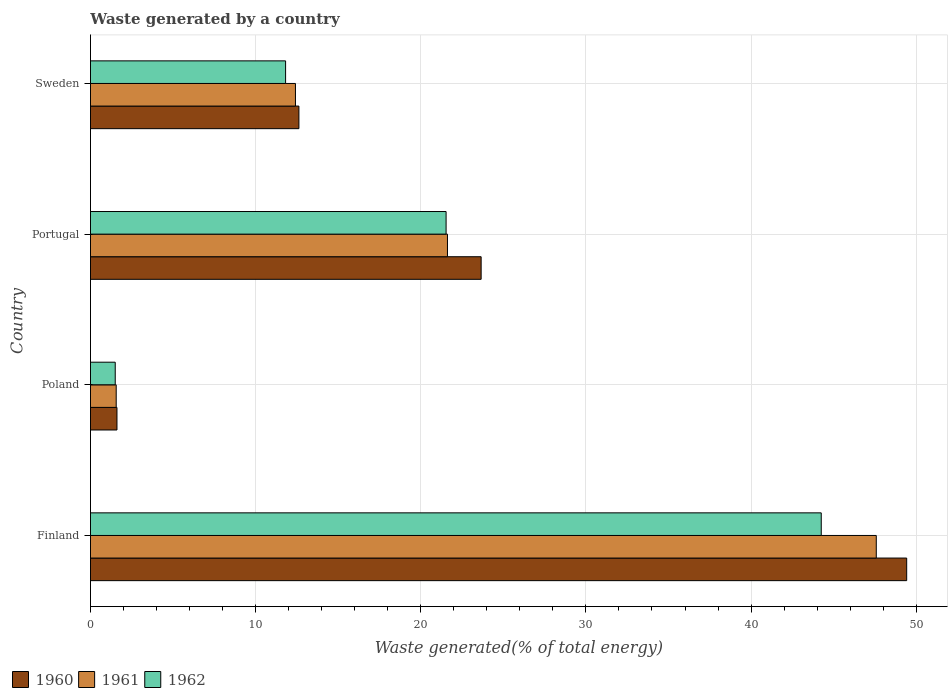Are the number of bars per tick equal to the number of legend labels?
Ensure brevity in your answer.  Yes. How many bars are there on the 4th tick from the top?
Make the answer very short. 3. What is the total waste generated in 1960 in Sweden?
Provide a succinct answer. 12.62. Across all countries, what is the maximum total waste generated in 1960?
Offer a terse response. 49.42. Across all countries, what is the minimum total waste generated in 1961?
Your answer should be compact. 1.56. In which country was the total waste generated in 1961 maximum?
Provide a succinct answer. Finland. What is the total total waste generated in 1960 in the graph?
Ensure brevity in your answer.  87.31. What is the difference between the total waste generated in 1960 in Finland and that in Portugal?
Offer a terse response. 25.77. What is the difference between the total waste generated in 1962 in Sweden and the total waste generated in 1960 in Portugal?
Give a very brief answer. -11.84. What is the average total waste generated in 1961 per country?
Make the answer very short. 20.79. What is the difference between the total waste generated in 1962 and total waste generated in 1961 in Finland?
Your answer should be compact. -3.33. What is the ratio of the total waste generated in 1960 in Poland to that in Sweden?
Ensure brevity in your answer.  0.13. Is the total waste generated in 1961 in Finland less than that in Portugal?
Make the answer very short. No. What is the difference between the highest and the second highest total waste generated in 1962?
Offer a very short reply. 22.72. What is the difference between the highest and the lowest total waste generated in 1961?
Ensure brevity in your answer.  46.02. In how many countries, is the total waste generated in 1962 greater than the average total waste generated in 1962 taken over all countries?
Make the answer very short. 2. Is the sum of the total waste generated in 1962 in Portugal and Sweden greater than the maximum total waste generated in 1960 across all countries?
Your answer should be very brief. No. Is it the case that in every country, the sum of the total waste generated in 1962 and total waste generated in 1960 is greater than the total waste generated in 1961?
Provide a short and direct response. Yes. Are all the bars in the graph horizontal?
Make the answer very short. Yes. How many countries are there in the graph?
Keep it short and to the point. 4. Does the graph contain any zero values?
Offer a terse response. No. Where does the legend appear in the graph?
Offer a very short reply. Bottom left. How many legend labels are there?
Provide a short and direct response. 3. How are the legend labels stacked?
Your answer should be compact. Horizontal. What is the title of the graph?
Provide a short and direct response. Waste generated by a country. What is the label or title of the X-axis?
Keep it short and to the point. Waste generated(% of total energy). What is the Waste generated(% of total energy) of 1960 in Finland?
Offer a terse response. 49.42. What is the Waste generated(% of total energy) of 1961 in Finland?
Ensure brevity in your answer.  47.58. What is the Waste generated(% of total energy) in 1962 in Finland?
Your answer should be very brief. 44.25. What is the Waste generated(% of total energy) of 1960 in Poland?
Your response must be concise. 1.6. What is the Waste generated(% of total energy) of 1961 in Poland?
Offer a very short reply. 1.56. What is the Waste generated(% of total energy) of 1962 in Poland?
Give a very brief answer. 1.5. What is the Waste generated(% of total energy) of 1960 in Portugal?
Give a very brief answer. 23.66. What is the Waste generated(% of total energy) of 1961 in Portugal?
Offer a very short reply. 21.62. What is the Waste generated(% of total energy) of 1962 in Portugal?
Your answer should be very brief. 21.53. What is the Waste generated(% of total energy) of 1960 in Sweden?
Your response must be concise. 12.62. What is the Waste generated(% of total energy) in 1961 in Sweden?
Offer a very short reply. 12.41. What is the Waste generated(% of total energy) in 1962 in Sweden?
Keep it short and to the point. 11.82. Across all countries, what is the maximum Waste generated(% of total energy) of 1960?
Ensure brevity in your answer.  49.42. Across all countries, what is the maximum Waste generated(% of total energy) in 1961?
Keep it short and to the point. 47.58. Across all countries, what is the maximum Waste generated(% of total energy) in 1962?
Your response must be concise. 44.25. Across all countries, what is the minimum Waste generated(% of total energy) of 1960?
Make the answer very short. 1.6. Across all countries, what is the minimum Waste generated(% of total energy) in 1961?
Offer a very short reply. 1.56. Across all countries, what is the minimum Waste generated(% of total energy) in 1962?
Make the answer very short. 1.5. What is the total Waste generated(% of total energy) of 1960 in the graph?
Ensure brevity in your answer.  87.31. What is the total Waste generated(% of total energy) in 1961 in the graph?
Offer a terse response. 83.17. What is the total Waste generated(% of total energy) of 1962 in the graph?
Offer a very short reply. 79.1. What is the difference between the Waste generated(% of total energy) in 1960 in Finland and that in Poland?
Provide a succinct answer. 47.82. What is the difference between the Waste generated(% of total energy) of 1961 in Finland and that in Poland?
Your answer should be compact. 46.02. What is the difference between the Waste generated(% of total energy) of 1962 in Finland and that in Poland?
Offer a very short reply. 42.75. What is the difference between the Waste generated(% of total energy) of 1960 in Finland and that in Portugal?
Keep it short and to the point. 25.77. What is the difference between the Waste generated(% of total energy) of 1961 in Finland and that in Portugal?
Your answer should be very brief. 25.96. What is the difference between the Waste generated(% of total energy) in 1962 in Finland and that in Portugal?
Provide a short and direct response. 22.72. What is the difference between the Waste generated(% of total energy) of 1960 in Finland and that in Sweden?
Offer a terse response. 36.8. What is the difference between the Waste generated(% of total energy) of 1961 in Finland and that in Sweden?
Make the answer very short. 35.17. What is the difference between the Waste generated(% of total energy) in 1962 in Finland and that in Sweden?
Your response must be concise. 32.44. What is the difference between the Waste generated(% of total energy) of 1960 in Poland and that in Portugal?
Ensure brevity in your answer.  -22.05. What is the difference between the Waste generated(% of total energy) in 1961 in Poland and that in Portugal?
Offer a very short reply. -20.06. What is the difference between the Waste generated(% of total energy) of 1962 in Poland and that in Portugal?
Provide a succinct answer. -20.03. What is the difference between the Waste generated(% of total energy) of 1960 in Poland and that in Sweden?
Your response must be concise. -11.02. What is the difference between the Waste generated(% of total energy) of 1961 in Poland and that in Sweden?
Offer a terse response. -10.85. What is the difference between the Waste generated(% of total energy) in 1962 in Poland and that in Sweden?
Provide a short and direct response. -10.32. What is the difference between the Waste generated(% of total energy) in 1960 in Portugal and that in Sweden?
Offer a very short reply. 11.03. What is the difference between the Waste generated(% of total energy) of 1961 in Portugal and that in Sweden?
Your answer should be compact. 9.2. What is the difference between the Waste generated(% of total energy) of 1962 in Portugal and that in Sweden?
Ensure brevity in your answer.  9.72. What is the difference between the Waste generated(% of total energy) of 1960 in Finland and the Waste generated(% of total energy) of 1961 in Poland?
Offer a very short reply. 47.86. What is the difference between the Waste generated(% of total energy) in 1960 in Finland and the Waste generated(% of total energy) in 1962 in Poland?
Provide a succinct answer. 47.92. What is the difference between the Waste generated(% of total energy) in 1961 in Finland and the Waste generated(% of total energy) in 1962 in Poland?
Your answer should be compact. 46.08. What is the difference between the Waste generated(% of total energy) of 1960 in Finland and the Waste generated(% of total energy) of 1961 in Portugal?
Offer a terse response. 27.81. What is the difference between the Waste generated(% of total energy) of 1960 in Finland and the Waste generated(% of total energy) of 1962 in Portugal?
Your answer should be compact. 27.89. What is the difference between the Waste generated(% of total energy) of 1961 in Finland and the Waste generated(% of total energy) of 1962 in Portugal?
Offer a terse response. 26.05. What is the difference between the Waste generated(% of total energy) in 1960 in Finland and the Waste generated(% of total energy) in 1961 in Sweden?
Give a very brief answer. 37.01. What is the difference between the Waste generated(% of total energy) of 1960 in Finland and the Waste generated(% of total energy) of 1962 in Sweden?
Your answer should be very brief. 37.61. What is the difference between the Waste generated(% of total energy) of 1961 in Finland and the Waste generated(% of total energy) of 1962 in Sweden?
Your answer should be very brief. 35.77. What is the difference between the Waste generated(% of total energy) in 1960 in Poland and the Waste generated(% of total energy) in 1961 in Portugal?
Provide a short and direct response. -20.01. What is the difference between the Waste generated(% of total energy) of 1960 in Poland and the Waste generated(% of total energy) of 1962 in Portugal?
Make the answer very short. -19.93. What is the difference between the Waste generated(% of total energy) in 1961 in Poland and the Waste generated(% of total energy) in 1962 in Portugal?
Make the answer very short. -19.98. What is the difference between the Waste generated(% of total energy) of 1960 in Poland and the Waste generated(% of total energy) of 1961 in Sweden?
Keep it short and to the point. -10.81. What is the difference between the Waste generated(% of total energy) in 1960 in Poland and the Waste generated(% of total energy) in 1962 in Sweden?
Provide a succinct answer. -10.21. What is the difference between the Waste generated(% of total energy) in 1961 in Poland and the Waste generated(% of total energy) in 1962 in Sweden?
Your response must be concise. -10.26. What is the difference between the Waste generated(% of total energy) of 1960 in Portugal and the Waste generated(% of total energy) of 1961 in Sweden?
Your answer should be very brief. 11.24. What is the difference between the Waste generated(% of total energy) in 1960 in Portugal and the Waste generated(% of total energy) in 1962 in Sweden?
Your answer should be compact. 11.84. What is the difference between the Waste generated(% of total energy) in 1961 in Portugal and the Waste generated(% of total energy) in 1962 in Sweden?
Your response must be concise. 9.8. What is the average Waste generated(% of total energy) in 1960 per country?
Provide a short and direct response. 21.83. What is the average Waste generated(% of total energy) in 1961 per country?
Your answer should be very brief. 20.79. What is the average Waste generated(% of total energy) of 1962 per country?
Your answer should be compact. 19.77. What is the difference between the Waste generated(% of total energy) in 1960 and Waste generated(% of total energy) in 1961 in Finland?
Your answer should be compact. 1.84. What is the difference between the Waste generated(% of total energy) of 1960 and Waste generated(% of total energy) of 1962 in Finland?
Keep it short and to the point. 5.17. What is the difference between the Waste generated(% of total energy) of 1961 and Waste generated(% of total energy) of 1962 in Finland?
Offer a very short reply. 3.33. What is the difference between the Waste generated(% of total energy) of 1960 and Waste generated(% of total energy) of 1961 in Poland?
Provide a succinct answer. 0.05. What is the difference between the Waste generated(% of total energy) in 1960 and Waste generated(% of total energy) in 1962 in Poland?
Your answer should be compact. 0.11. What is the difference between the Waste generated(% of total energy) in 1961 and Waste generated(% of total energy) in 1962 in Poland?
Offer a terse response. 0.06. What is the difference between the Waste generated(% of total energy) of 1960 and Waste generated(% of total energy) of 1961 in Portugal?
Offer a terse response. 2.04. What is the difference between the Waste generated(% of total energy) of 1960 and Waste generated(% of total energy) of 1962 in Portugal?
Provide a succinct answer. 2.12. What is the difference between the Waste generated(% of total energy) of 1961 and Waste generated(% of total energy) of 1962 in Portugal?
Make the answer very short. 0.08. What is the difference between the Waste generated(% of total energy) in 1960 and Waste generated(% of total energy) in 1961 in Sweden?
Provide a short and direct response. 0.21. What is the difference between the Waste generated(% of total energy) in 1960 and Waste generated(% of total energy) in 1962 in Sweden?
Offer a very short reply. 0.81. What is the difference between the Waste generated(% of total energy) of 1961 and Waste generated(% of total energy) of 1962 in Sweden?
Offer a terse response. 0.6. What is the ratio of the Waste generated(% of total energy) of 1960 in Finland to that in Poland?
Offer a very short reply. 30.8. What is the ratio of the Waste generated(% of total energy) of 1961 in Finland to that in Poland?
Your answer should be very brief. 30.53. What is the ratio of the Waste generated(% of total energy) of 1962 in Finland to that in Poland?
Keep it short and to the point. 29.52. What is the ratio of the Waste generated(% of total energy) of 1960 in Finland to that in Portugal?
Ensure brevity in your answer.  2.09. What is the ratio of the Waste generated(% of total energy) of 1961 in Finland to that in Portugal?
Offer a very short reply. 2.2. What is the ratio of the Waste generated(% of total energy) in 1962 in Finland to that in Portugal?
Provide a succinct answer. 2.05. What is the ratio of the Waste generated(% of total energy) of 1960 in Finland to that in Sweden?
Ensure brevity in your answer.  3.92. What is the ratio of the Waste generated(% of total energy) in 1961 in Finland to that in Sweden?
Ensure brevity in your answer.  3.83. What is the ratio of the Waste generated(% of total energy) of 1962 in Finland to that in Sweden?
Offer a very short reply. 3.75. What is the ratio of the Waste generated(% of total energy) in 1960 in Poland to that in Portugal?
Provide a short and direct response. 0.07. What is the ratio of the Waste generated(% of total energy) in 1961 in Poland to that in Portugal?
Ensure brevity in your answer.  0.07. What is the ratio of the Waste generated(% of total energy) in 1962 in Poland to that in Portugal?
Your response must be concise. 0.07. What is the ratio of the Waste generated(% of total energy) of 1960 in Poland to that in Sweden?
Your answer should be very brief. 0.13. What is the ratio of the Waste generated(% of total energy) in 1961 in Poland to that in Sweden?
Offer a terse response. 0.13. What is the ratio of the Waste generated(% of total energy) in 1962 in Poland to that in Sweden?
Offer a very short reply. 0.13. What is the ratio of the Waste generated(% of total energy) in 1960 in Portugal to that in Sweden?
Your answer should be compact. 1.87. What is the ratio of the Waste generated(% of total energy) in 1961 in Portugal to that in Sweden?
Give a very brief answer. 1.74. What is the ratio of the Waste generated(% of total energy) of 1962 in Portugal to that in Sweden?
Your answer should be very brief. 1.82. What is the difference between the highest and the second highest Waste generated(% of total energy) of 1960?
Ensure brevity in your answer.  25.77. What is the difference between the highest and the second highest Waste generated(% of total energy) of 1961?
Provide a short and direct response. 25.96. What is the difference between the highest and the second highest Waste generated(% of total energy) in 1962?
Your answer should be very brief. 22.72. What is the difference between the highest and the lowest Waste generated(% of total energy) of 1960?
Make the answer very short. 47.82. What is the difference between the highest and the lowest Waste generated(% of total energy) in 1961?
Provide a succinct answer. 46.02. What is the difference between the highest and the lowest Waste generated(% of total energy) of 1962?
Provide a succinct answer. 42.75. 